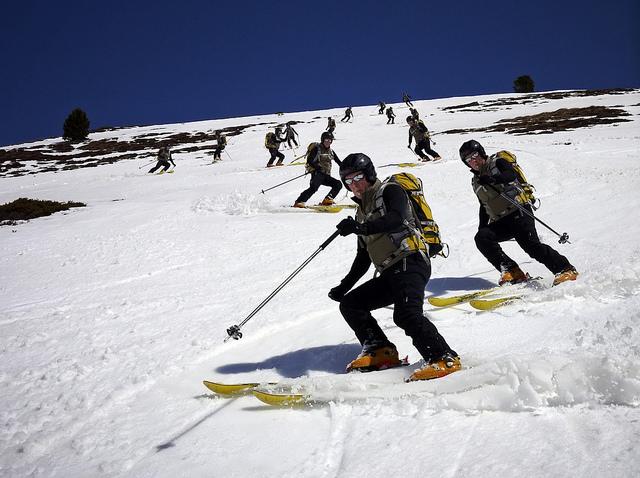Is this multiple skiers or one single skier?
Concise answer only. 1. Are all the skiers going in the same direction?
Short answer required. No. How many bushes do you see?
Quick response, please. 2. 